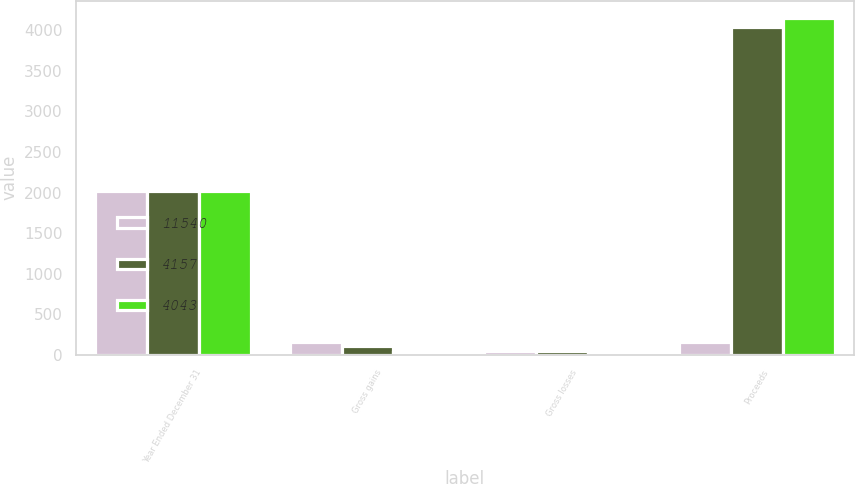Convert chart to OTSL. <chart><loc_0><loc_0><loc_500><loc_500><stacked_bar_chart><ecel><fcel>Year Ended December 31<fcel>Gross gains<fcel>Gross losses<fcel>Proceeds<nl><fcel>11540<fcel>2016<fcel>152<fcel>51<fcel>152<nl><fcel>4157<fcel>2015<fcel>103<fcel>42<fcel>4043<nl><fcel>4043<fcel>2014<fcel>38<fcel>21<fcel>4157<nl></chart> 